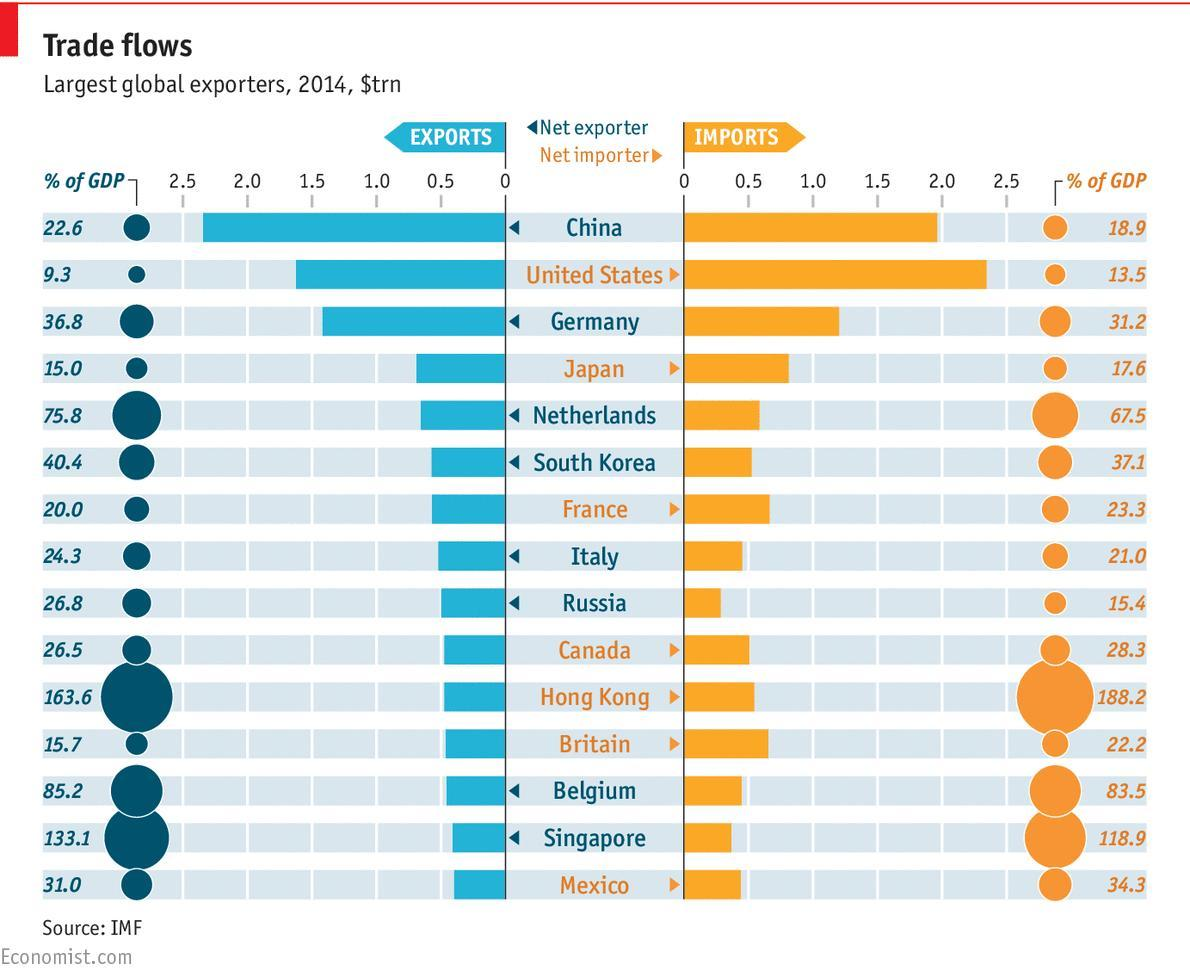Which color is used to represent imports-blue, orange, or white?
Answer the question with a short phrase. orange Which color is used to represent exports-orange, blue, or white? blue 